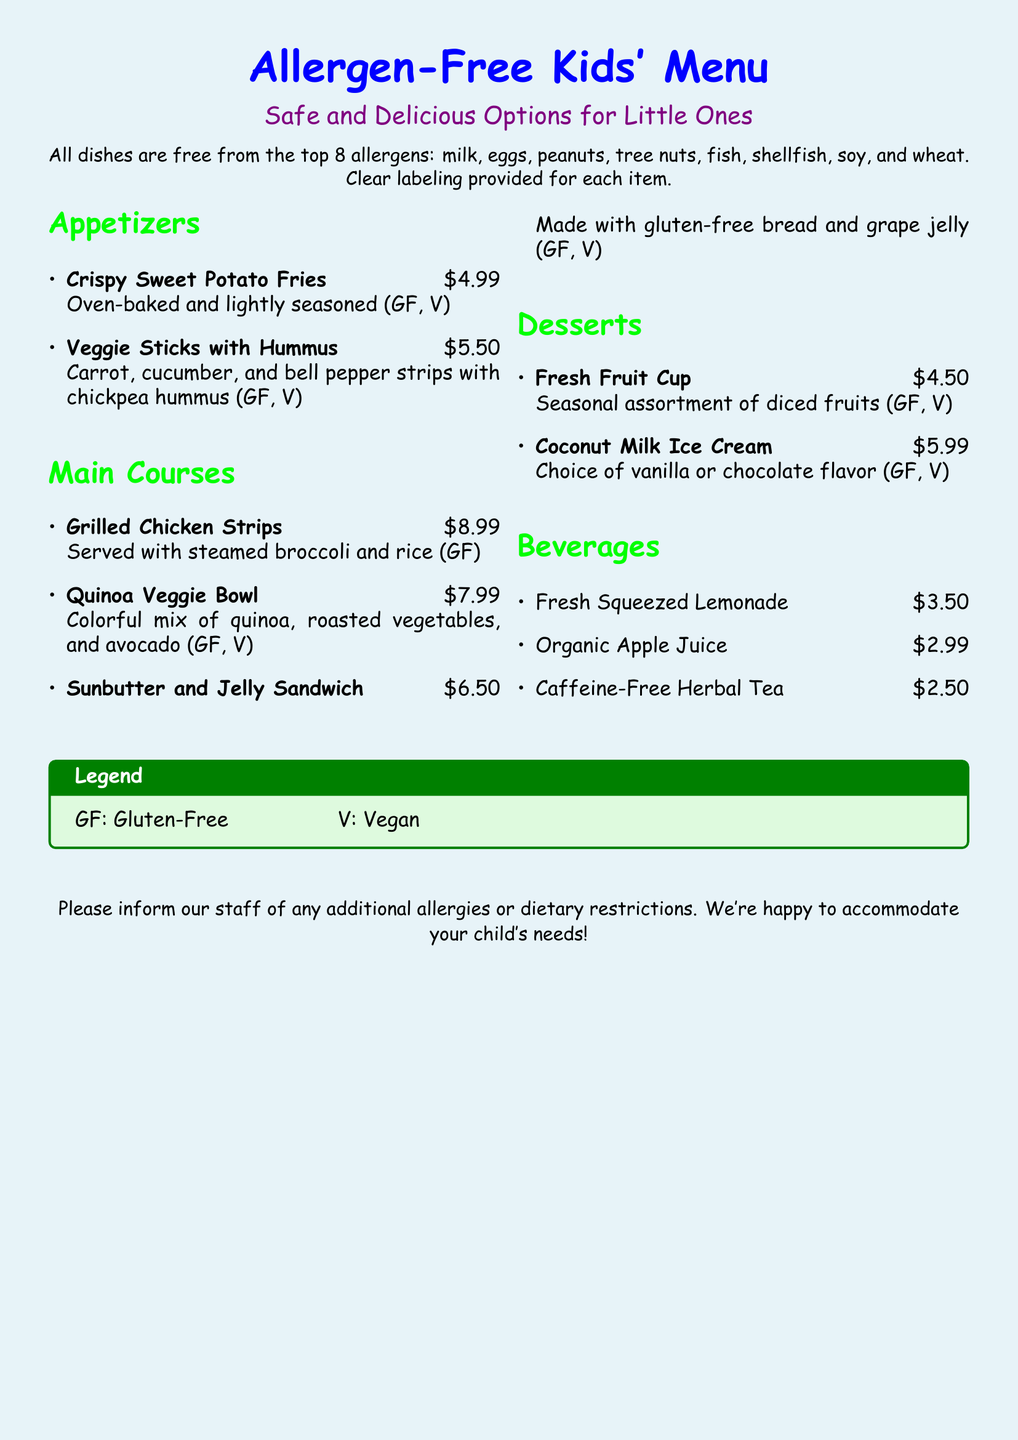what types of allergies are accommodated? The document states that all dishes are free from the top 8 allergens: milk, eggs, peanuts, tree nuts, fish, shellfish, soy, and wheat.
Answer: top 8 allergens how much do Crispy Sweet Potato Fries cost? The listed price for Crispy Sweet Potato Fries in the appetizers section is $4.99.
Answer: $4.99 which item is made with gluten-free bread? The Sunbutter and Jelly Sandwich is specifically mentioned to be made with gluten-free bread.
Answer: Sunbutter and Jelly Sandwich how many desserts are on the menu? The menu includes two dessert options: Fresh Fruit Cup and Coconut Milk Ice Cream.
Answer: 2 what dietary labels are used in the menu? The menu uses GF for Gluten-Free and V for Vegan.
Answer: GF, V what is the price of the Quinoa Veggie Bowl? The Quinoa Veggie Bowl is priced at $7.99 according to the main courses section.
Answer: $7.99 what is the beverage option available for $2.50? Caffeine-Free Herbal Tea is the beverage that costs $2.50.
Answer: Caffeine-Free Herbal Tea which dessert option offers a choice of flavor? The Coconut Milk Ice Cream allows customers to choose between vanilla or chocolate flavor.
Answer: Coconut Milk Ice Cream 